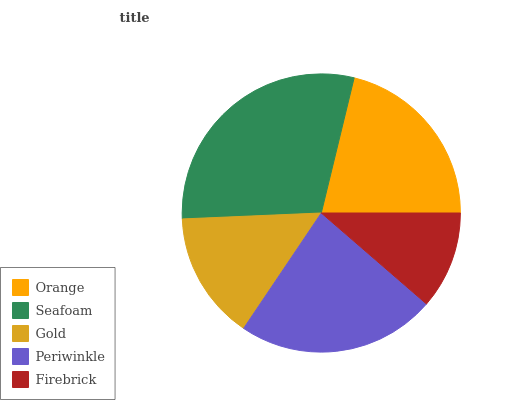Is Firebrick the minimum?
Answer yes or no. Yes. Is Seafoam the maximum?
Answer yes or no. Yes. Is Gold the minimum?
Answer yes or no. No. Is Gold the maximum?
Answer yes or no. No. Is Seafoam greater than Gold?
Answer yes or no. Yes. Is Gold less than Seafoam?
Answer yes or no. Yes. Is Gold greater than Seafoam?
Answer yes or no. No. Is Seafoam less than Gold?
Answer yes or no. No. Is Orange the high median?
Answer yes or no. Yes. Is Orange the low median?
Answer yes or no. Yes. Is Seafoam the high median?
Answer yes or no. No. Is Seafoam the low median?
Answer yes or no. No. 